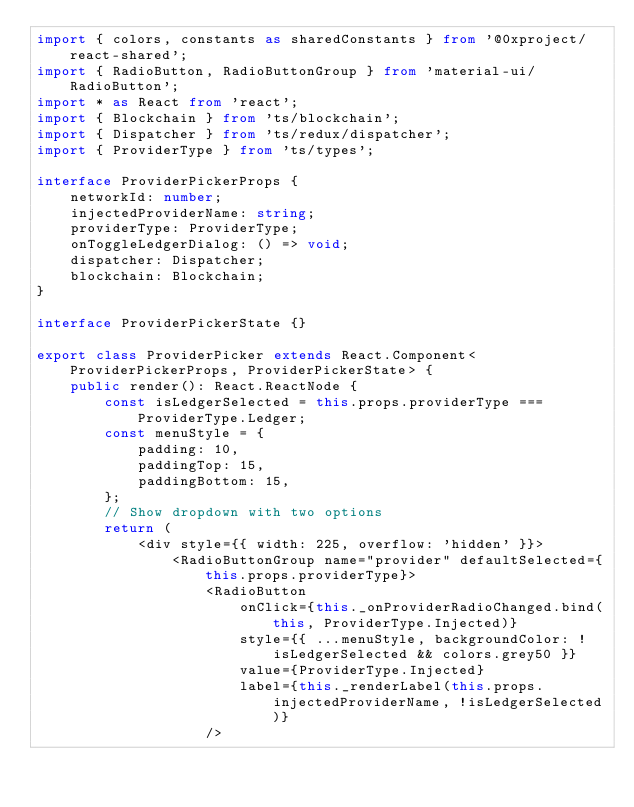<code> <loc_0><loc_0><loc_500><loc_500><_TypeScript_>import { colors, constants as sharedConstants } from '@0xproject/react-shared';
import { RadioButton, RadioButtonGroup } from 'material-ui/RadioButton';
import * as React from 'react';
import { Blockchain } from 'ts/blockchain';
import { Dispatcher } from 'ts/redux/dispatcher';
import { ProviderType } from 'ts/types';

interface ProviderPickerProps {
    networkId: number;
    injectedProviderName: string;
    providerType: ProviderType;
    onToggleLedgerDialog: () => void;
    dispatcher: Dispatcher;
    blockchain: Blockchain;
}

interface ProviderPickerState {}

export class ProviderPicker extends React.Component<ProviderPickerProps, ProviderPickerState> {
    public render(): React.ReactNode {
        const isLedgerSelected = this.props.providerType === ProviderType.Ledger;
        const menuStyle = {
            padding: 10,
            paddingTop: 15,
            paddingBottom: 15,
        };
        // Show dropdown with two options
        return (
            <div style={{ width: 225, overflow: 'hidden' }}>
                <RadioButtonGroup name="provider" defaultSelected={this.props.providerType}>
                    <RadioButton
                        onClick={this._onProviderRadioChanged.bind(this, ProviderType.Injected)}
                        style={{ ...menuStyle, backgroundColor: !isLedgerSelected && colors.grey50 }}
                        value={ProviderType.Injected}
                        label={this._renderLabel(this.props.injectedProviderName, !isLedgerSelected)}
                    /></code> 